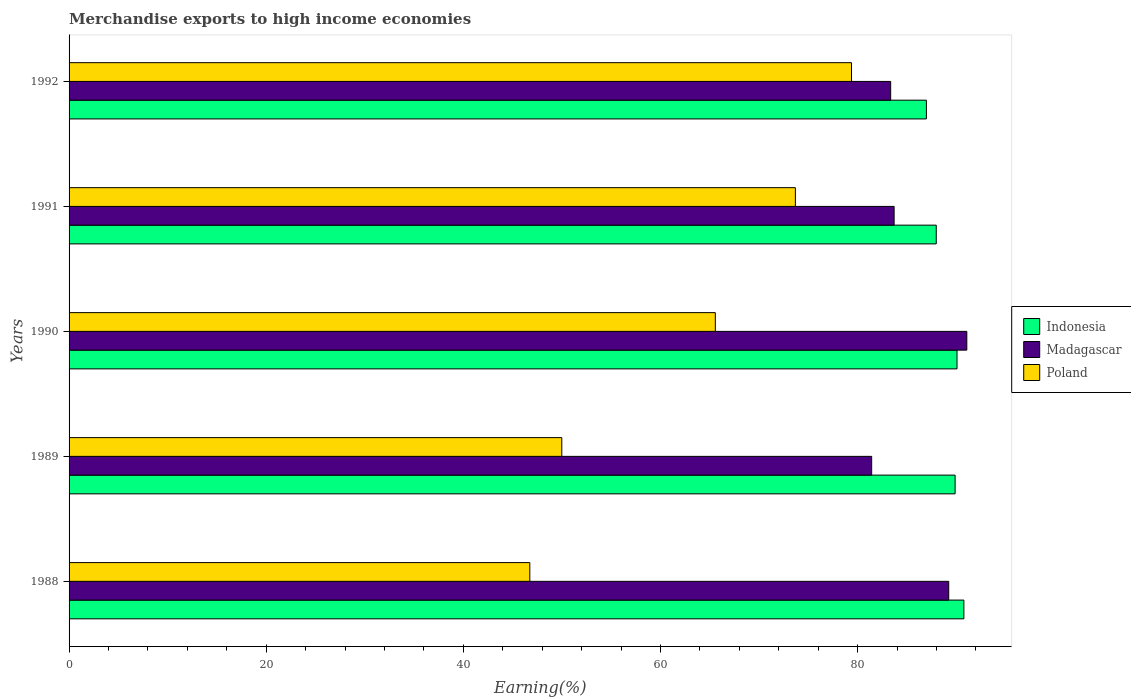How many different coloured bars are there?
Your answer should be compact. 3. How many groups of bars are there?
Offer a very short reply. 5. Are the number of bars per tick equal to the number of legend labels?
Your answer should be very brief. Yes. What is the label of the 1st group of bars from the top?
Provide a succinct answer. 1992. What is the percentage of amount earned from merchandise exports in Poland in 1990?
Your answer should be compact. 65.56. Across all years, what is the maximum percentage of amount earned from merchandise exports in Indonesia?
Offer a terse response. 90.77. Across all years, what is the minimum percentage of amount earned from merchandise exports in Indonesia?
Your answer should be compact. 86.97. In which year was the percentage of amount earned from merchandise exports in Poland maximum?
Give a very brief answer. 1992. In which year was the percentage of amount earned from merchandise exports in Poland minimum?
Make the answer very short. 1988. What is the total percentage of amount earned from merchandise exports in Madagascar in the graph?
Offer a terse response. 428.76. What is the difference between the percentage of amount earned from merchandise exports in Indonesia in 1988 and that in 1991?
Your response must be concise. 2.8. What is the difference between the percentage of amount earned from merchandise exports in Madagascar in 1990 and the percentage of amount earned from merchandise exports in Indonesia in 1988?
Provide a succinct answer. 0.3. What is the average percentage of amount earned from merchandise exports in Indonesia per year?
Your response must be concise. 89.13. In the year 1988, what is the difference between the percentage of amount earned from merchandise exports in Indonesia and percentage of amount earned from merchandise exports in Poland?
Give a very brief answer. 44.03. In how many years, is the percentage of amount earned from merchandise exports in Indonesia greater than 88 %?
Keep it short and to the point. 3. What is the ratio of the percentage of amount earned from merchandise exports in Poland in 1989 to that in 1990?
Ensure brevity in your answer.  0.76. What is the difference between the highest and the second highest percentage of amount earned from merchandise exports in Poland?
Your answer should be very brief. 5.69. What is the difference between the highest and the lowest percentage of amount earned from merchandise exports in Indonesia?
Your answer should be very brief. 3.8. What does the 2nd bar from the top in 1992 represents?
Provide a short and direct response. Madagascar. What does the 2nd bar from the bottom in 1990 represents?
Ensure brevity in your answer.  Madagascar. How many bars are there?
Give a very brief answer. 15. Are all the bars in the graph horizontal?
Make the answer very short. Yes. Does the graph contain any zero values?
Keep it short and to the point. No. How are the legend labels stacked?
Offer a very short reply. Vertical. What is the title of the graph?
Your answer should be very brief. Merchandise exports to high income economies. What is the label or title of the X-axis?
Make the answer very short. Earning(%). What is the label or title of the Y-axis?
Keep it short and to the point. Years. What is the Earning(%) of Indonesia in 1988?
Your answer should be compact. 90.77. What is the Earning(%) of Madagascar in 1988?
Keep it short and to the point. 89.24. What is the Earning(%) of Poland in 1988?
Offer a terse response. 46.74. What is the Earning(%) in Indonesia in 1989?
Your response must be concise. 89.88. What is the Earning(%) of Madagascar in 1989?
Make the answer very short. 81.42. What is the Earning(%) in Poland in 1989?
Give a very brief answer. 49.98. What is the Earning(%) of Indonesia in 1990?
Give a very brief answer. 90.08. What is the Earning(%) in Madagascar in 1990?
Provide a succinct answer. 91.07. What is the Earning(%) of Poland in 1990?
Make the answer very short. 65.56. What is the Earning(%) of Indonesia in 1991?
Offer a very short reply. 87.97. What is the Earning(%) in Madagascar in 1991?
Offer a very short reply. 83.7. What is the Earning(%) in Poland in 1991?
Your answer should be very brief. 73.68. What is the Earning(%) of Indonesia in 1992?
Make the answer very short. 86.97. What is the Earning(%) of Madagascar in 1992?
Make the answer very short. 83.35. What is the Earning(%) of Poland in 1992?
Make the answer very short. 79.37. Across all years, what is the maximum Earning(%) in Indonesia?
Ensure brevity in your answer.  90.77. Across all years, what is the maximum Earning(%) of Madagascar?
Provide a short and direct response. 91.07. Across all years, what is the maximum Earning(%) of Poland?
Your answer should be very brief. 79.37. Across all years, what is the minimum Earning(%) in Indonesia?
Ensure brevity in your answer.  86.97. Across all years, what is the minimum Earning(%) of Madagascar?
Your answer should be very brief. 81.42. Across all years, what is the minimum Earning(%) in Poland?
Your response must be concise. 46.74. What is the total Earning(%) in Indonesia in the graph?
Give a very brief answer. 445.67. What is the total Earning(%) in Madagascar in the graph?
Ensure brevity in your answer.  428.76. What is the total Earning(%) of Poland in the graph?
Your answer should be compact. 315.33. What is the difference between the Earning(%) of Indonesia in 1988 and that in 1989?
Offer a very short reply. 0.89. What is the difference between the Earning(%) of Madagascar in 1988 and that in 1989?
Provide a short and direct response. 7.82. What is the difference between the Earning(%) of Poland in 1988 and that in 1989?
Keep it short and to the point. -3.24. What is the difference between the Earning(%) in Indonesia in 1988 and that in 1990?
Make the answer very short. 0.7. What is the difference between the Earning(%) in Madagascar in 1988 and that in 1990?
Keep it short and to the point. -1.83. What is the difference between the Earning(%) in Poland in 1988 and that in 1990?
Offer a very short reply. -18.82. What is the difference between the Earning(%) in Indonesia in 1988 and that in 1991?
Give a very brief answer. 2.8. What is the difference between the Earning(%) of Madagascar in 1988 and that in 1991?
Keep it short and to the point. 5.54. What is the difference between the Earning(%) in Poland in 1988 and that in 1991?
Your answer should be compact. -26.94. What is the difference between the Earning(%) in Indonesia in 1988 and that in 1992?
Make the answer very short. 3.8. What is the difference between the Earning(%) of Madagascar in 1988 and that in 1992?
Give a very brief answer. 5.89. What is the difference between the Earning(%) in Poland in 1988 and that in 1992?
Your response must be concise. -32.63. What is the difference between the Earning(%) in Indonesia in 1989 and that in 1990?
Offer a terse response. -0.19. What is the difference between the Earning(%) of Madagascar in 1989 and that in 1990?
Provide a succinct answer. -9.65. What is the difference between the Earning(%) in Poland in 1989 and that in 1990?
Offer a very short reply. -15.58. What is the difference between the Earning(%) in Indonesia in 1989 and that in 1991?
Provide a short and direct response. 1.91. What is the difference between the Earning(%) in Madagascar in 1989 and that in 1991?
Offer a terse response. -2.28. What is the difference between the Earning(%) in Poland in 1989 and that in 1991?
Your response must be concise. -23.7. What is the difference between the Earning(%) in Indonesia in 1989 and that in 1992?
Your response must be concise. 2.91. What is the difference between the Earning(%) in Madagascar in 1989 and that in 1992?
Give a very brief answer. -1.93. What is the difference between the Earning(%) in Poland in 1989 and that in 1992?
Provide a succinct answer. -29.39. What is the difference between the Earning(%) in Indonesia in 1990 and that in 1991?
Keep it short and to the point. 2.11. What is the difference between the Earning(%) in Madagascar in 1990 and that in 1991?
Offer a terse response. 7.37. What is the difference between the Earning(%) of Poland in 1990 and that in 1991?
Offer a very short reply. -8.12. What is the difference between the Earning(%) of Indonesia in 1990 and that in 1992?
Provide a short and direct response. 3.11. What is the difference between the Earning(%) of Madagascar in 1990 and that in 1992?
Keep it short and to the point. 7.72. What is the difference between the Earning(%) in Poland in 1990 and that in 1992?
Your response must be concise. -13.81. What is the difference between the Earning(%) in Indonesia in 1991 and that in 1992?
Ensure brevity in your answer.  1. What is the difference between the Earning(%) of Madagascar in 1991 and that in 1992?
Keep it short and to the point. 0.35. What is the difference between the Earning(%) of Poland in 1991 and that in 1992?
Your answer should be very brief. -5.69. What is the difference between the Earning(%) in Indonesia in 1988 and the Earning(%) in Madagascar in 1989?
Your answer should be compact. 9.35. What is the difference between the Earning(%) in Indonesia in 1988 and the Earning(%) in Poland in 1989?
Provide a succinct answer. 40.79. What is the difference between the Earning(%) in Madagascar in 1988 and the Earning(%) in Poland in 1989?
Ensure brevity in your answer.  39.25. What is the difference between the Earning(%) of Indonesia in 1988 and the Earning(%) of Madagascar in 1990?
Your response must be concise. -0.3. What is the difference between the Earning(%) of Indonesia in 1988 and the Earning(%) of Poland in 1990?
Ensure brevity in your answer.  25.21. What is the difference between the Earning(%) of Madagascar in 1988 and the Earning(%) of Poland in 1990?
Offer a terse response. 23.68. What is the difference between the Earning(%) in Indonesia in 1988 and the Earning(%) in Madagascar in 1991?
Make the answer very short. 7.08. What is the difference between the Earning(%) of Indonesia in 1988 and the Earning(%) of Poland in 1991?
Offer a terse response. 17.09. What is the difference between the Earning(%) in Madagascar in 1988 and the Earning(%) in Poland in 1991?
Your answer should be very brief. 15.56. What is the difference between the Earning(%) of Indonesia in 1988 and the Earning(%) of Madagascar in 1992?
Your answer should be very brief. 7.43. What is the difference between the Earning(%) of Indonesia in 1988 and the Earning(%) of Poland in 1992?
Keep it short and to the point. 11.4. What is the difference between the Earning(%) in Madagascar in 1988 and the Earning(%) in Poland in 1992?
Your response must be concise. 9.87. What is the difference between the Earning(%) of Indonesia in 1989 and the Earning(%) of Madagascar in 1990?
Make the answer very short. -1.19. What is the difference between the Earning(%) of Indonesia in 1989 and the Earning(%) of Poland in 1990?
Offer a terse response. 24.32. What is the difference between the Earning(%) of Madagascar in 1989 and the Earning(%) of Poland in 1990?
Offer a terse response. 15.86. What is the difference between the Earning(%) of Indonesia in 1989 and the Earning(%) of Madagascar in 1991?
Your answer should be compact. 6.19. What is the difference between the Earning(%) in Indonesia in 1989 and the Earning(%) in Poland in 1991?
Offer a terse response. 16.2. What is the difference between the Earning(%) of Madagascar in 1989 and the Earning(%) of Poland in 1991?
Offer a very short reply. 7.74. What is the difference between the Earning(%) of Indonesia in 1989 and the Earning(%) of Madagascar in 1992?
Make the answer very short. 6.54. What is the difference between the Earning(%) in Indonesia in 1989 and the Earning(%) in Poland in 1992?
Ensure brevity in your answer.  10.51. What is the difference between the Earning(%) in Madagascar in 1989 and the Earning(%) in Poland in 1992?
Offer a terse response. 2.05. What is the difference between the Earning(%) of Indonesia in 1990 and the Earning(%) of Madagascar in 1991?
Provide a succinct answer. 6.38. What is the difference between the Earning(%) of Indonesia in 1990 and the Earning(%) of Poland in 1991?
Keep it short and to the point. 16.4. What is the difference between the Earning(%) of Madagascar in 1990 and the Earning(%) of Poland in 1991?
Provide a short and direct response. 17.39. What is the difference between the Earning(%) in Indonesia in 1990 and the Earning(%) in Madagascar in 1992?
Provide a succinct answer. 6.73. What is the difference between the Earning(%) in Indonesia in 1990 and the Earning(%) in Poland in 1992?
Give a very brief answer. 10.71. What is the difference between the Earning(%) of Madagascar in 1990 and the Earning(%) of Poland in 1992?
Provide a short and direct response. 11.7. What is the difference between the Earning(%) of Indonesia in 1991 and the Earning(%) of Madagascar in 1992?
Offer a terse response. 4.62. What is the difference between the Earning(%) of Indonesia in 1991 and the Earning(%) of Poland in 1992?
Offer a terse response. 8.6. What is the difference between the Earning(%) in Madagascar in 1991 and the Earning(%) in Poland in 1992?
Your response must be concise. 4.33. What is the average Earning(%) of Indonesia per year?
Offer a terse response. 89.13. What is the average Earning(%) in Madagascar per year?
Keep it short and to the point. 85.75. What is the average Earning(%) of Poland per year?
Your answer should be compact. 63.07. In the year 1988, what is the difference between the Earning(%) in Indonesia and Earning(%) in Madagascar?
Provide a succinct answer. 1.54. In the year 1988, what is the difference between the Earning(%) of Indonesia and Earning(%) of Poland?
Keep it short and to the point. 44.03. In the year 1988, what is the difference between the Earning(%) of Madagascar and Earning(%) of Poland?
Your answer should be very brief. 42.5. In the year 1989, what is the difference between the Earning(%) in Indonesia and Earning(%) in Madagascar?
Offer a very short reply. 8.46. In the year 1989, what is the difference between the Earning(%) in Indonesia and Earning(%) in Poland?
Make the answer very short. 39.9. In the year 1989, what is the difference between the Earning(%) of Madagascar and Earning(%) of Poland?
Your answer should be very brief. 31.43. In the year 1990, what is the difference between the Earning(%) of Indonesia and Earning(%) of Madagascar?
Provide a succinct answer. -0.99. In the year 1990, what is the difference between the Earning(%) of Indonesia and Earning(%) of Poland?
Provide a short and direct response. 24.52. In the year 1990, what is the difference between the Earning(%) in Madagascar and Earning(%) in Poland?
Make the answer very short. 25.51. In the year 1991, what is the difference between the Earning(%) of Indonesia and Earning(%) of Madagascar?
Your answer should be very brief. 4.27. In the year 1991, what is the difference between the Earning(%) of Indonesia and Earning(%) of Poland?
Offer a very short reply. 14.29. In the year 1991, what is the difference between the Earning(%) of Madagascar and Earning(%) of Poland?
Provide a succinct answer. 10.02. In the year 1992, what is the difference between the Earning(%) of Indonesia and Earning(%) of Madagascar?
Provide a short and direct response. 3.63. In the year 1992, what is the difference between the Earning(%) in Indonesia and Earning(%) in Poland?
Provide a short and direct response. 7.6. In the year 1992, what is the difference between the Earning(%) of Madagascar and Earning(%) of Poland?
Make the answer very short. 3.98. What is the ratio of the Earning(%) in Indonesia in 1988 to that in 1989?
Offer a very short reply. 1.01. What is the ratio of the Earning(%) of Madagascar in 1988 to that in 1989?
Ensure brevity in your answer.  1.1. What is the ratio of the Earning(%) of Poland in 1988 to that in 1989?
Your response must be concise. 0.94. What is the ratio of the Earning(%) of Indonesia in 1988 to that in 1990?
Your response must be concise. 1.01. What is the ratio of the Earning(%) in Madagascar in 1988 to that in 1990?
Keep it short and to the point. 0.98. What is the ratio of the Earning(%) in Poland in 1988 to that in 1990?
Provide a succinct answer. 0.71. What is the ratio of the Earning(%) of Indonesia in 1988 to that in 1991?
Your response must be concise. 1.03. What is the ratio of the Earning(%) in Madagascar in 1988 to that in 1991?
Give a very brief answer. 1.07. What is the ratio of the Earning(%) of Poland in 1988 to that in 1991?
Give a very brief answer. 0.63. What is the ratio of the Earning(%) in Indonesia in 1988 to that in 1992?
Your answer should be compact. 1.04. What is the ratio of the Earning(%) of Madagascar in 1988 to that in 1992?
Offer a very short reply. 1.07. What is the ratio of the Earning(%) of Poland in 1988 to that in 1992?
Provide a succinct answer. 0.59. What is the ratio of the Earning(%) in Madagascar in 1989 to that in 1990?
Your response must be concise. 0.89. What is the ratio of the Earning(%) in Poland in 1989 to that in 1990?
Provide a succinct answer. 0.76. What is the ratio of the Earning(%) of Indonesia in 1989 to that in 1991?
Provide a succinct answer. 1.02. What is the ratio of the Earning(%) in Madagascar in 1989 to that in 1991?
Offer a terse response. 0.97. What is the ratio of the Earning(%) in Poland in 1989 to that in 1991?
Provide a succinct answer. 0.68. What is the ratio of the Earning(%) of Indonesia in 1989 to that in 1992?
Your answer should be very brief. 1.03. What is the ratio of the Earning(%) in Madagascar in 1989 to that in 1992?
Provide a short and direct response. 0.98. What is the ratio of the Earning(%) of Poland in 1989 to that in 1992?
Provide a succinct answer. 0.63. What is the ratio of the Earning(%) of Indonesia in 1990 to that in 1991?
Make the answer very short. 1.02. What is the ratio of the Earning(%) in Madagascar in 1990 to that in 1991?
Keep it short and to the point. 1.09. What is the ratio of the Earning(%) of Poland in 1990 to that in 1991?
Offer a very short reply. 0.89. What is the ratio of the Earning(%) in Indonesia in 1990 to that in 1992?
Your answer should be very brief. 1.04. What is the ratio of the Earning(%) of Madagascar in 1990 to that in 1992?
Provide a short and direct response. 1.09. What is the ratio of the Earning(%) in Poland in 1990 to that in 1992?
Offer a very short reply. 0.83. What is the ratio of the Earning(%) of Indonesia in 1991 to that in 1992?
Provide a succinct answer. 1.01. What is the ratio of the Earning(%) in Madagascar in 1991 to that in 1992?
Keep it short and to the point. 1. What is the ratio of the Earning(%) in Poland in 1991 to that in 1992?
Your answer should be very brief. 0.93. What is the difference between the highest and the second highest Earning(%) of Indonesia?
Make the answer very short. 0.7. What is the difference between the highest and the second highest Earning(%) of Madagascar?
Provide a short and direct response. 1.83. What is the difference between the highest and the second highest Earning(%) of Poland?
Provide a succinct answer. 5.69. What is the difference between the highest and the lowest Earning(%) in Indonesia?
Offer a terse response. 3.8. What is the difference between the highest and the lowest Earning(%) of Madagascar?
Offer a terse response. 9.65. What is the difference between the highest and the lowest Earning(%) in Poland?
Provide a succinct answer. 32.63. 